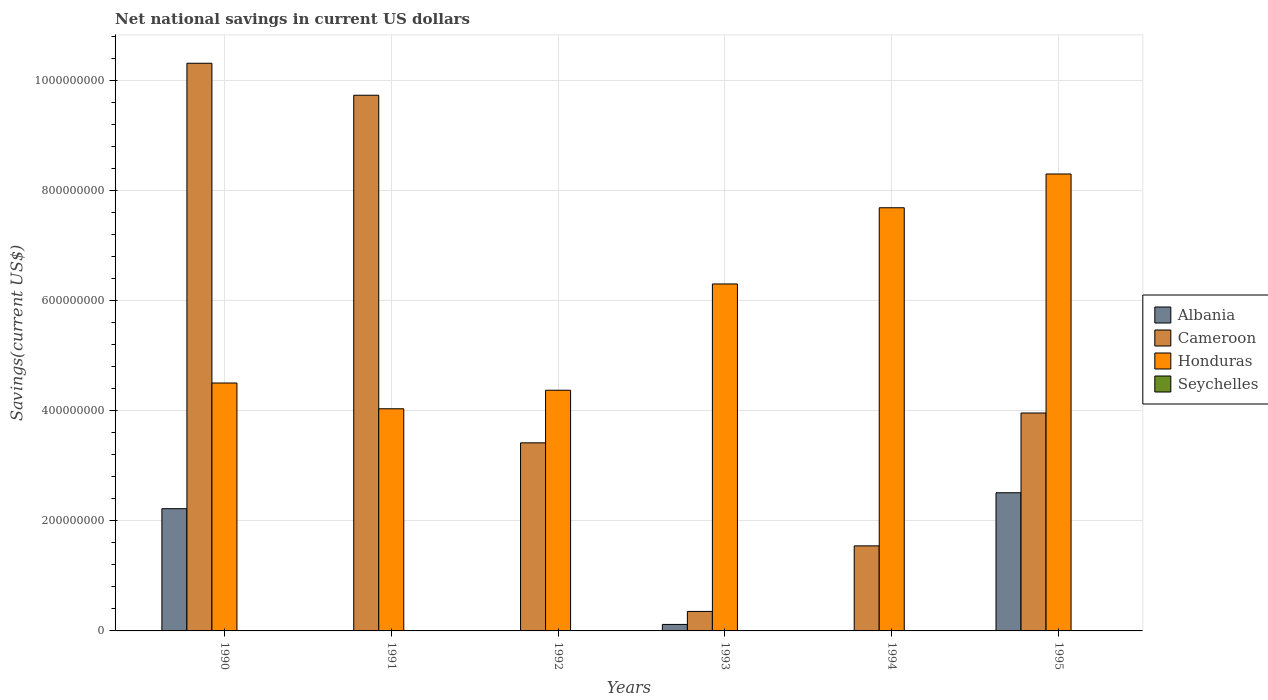How many groups of bars are there?
Keep it short and to the point. 6. Are the number of bars per tick equal to the number of legend labels?
Offer a terse response. No. Are the number of bars on each tick of the X-axis equal?
Keep it short and to the point. No. How many bars are there on the 6th tick from the right?
Give a very brief answer. 3. What is the net national savings in Albania in 1994?
Give a very brief answer. 0. Across all years, what is the maximum net national savings in Cameroon?
Offer a very short reply. 1.03e+09. Across all years, what is the minimum net national savings in Cameroon?
Your response must be concise. 3.54e+07. What is the difference between the net national savings in Honduras in 1994 and that in 1995?
Offer a terse response. -6.14e+07. What is the difference between the net national savings in Cameroon in 1992 and the net national savings in Honduras in 1993?
Your answer should be compact. -2.89e+08. What is the average net national savings in Albania per year?
Provide a short and direct response. 8.09e+07. In the year 1990, what is the difference between the net national savings in Honduras and net national savings in Cameroon?
Provide a short and direct response. -5.81e+08. What is the ratio of the net national savings in Cameroon in 1992 to that in 1994?
Provide a succinct answer. 2.21. What is the difference between the highest and the second highest net national savings in Albania?
Your answer should be very brief. 2.90e+07. What is the difference between the highest and the lowest net national savings in Cameroon?
Keep it short and to the point. 9.96e+08. In how many years, is the net national savings in Honduras greater than the average net national savings in Honduras taken over all years?
Your answer should be very brief. 3. Is it the case that in every year, the sum of the net national savings in Cameroon and net national savings in Honduras is greater than the sum of net national savings in Albania and net national savings in Seychelles?
Provide a succinct answer. Yes. Is it the case that in every year, the sum of the net national savings in Seychelles and net national savings in Albania is greater than the net national savings in Cameroon?
Provide a succinct answer. No. How many bars are there?
Your answer should be very brief. 15. Are all the bars in the graph horizontal?
Offer a very short reply. No. What is the difference between two consecutive major ticks on the Y-axis?
Keep it short and to the point. 2.00e+08. Does the graph contain grids?
Provide a short and direct response. Yes. How many legend labels are there?
Ensure brevity in your answer.  4. How are the legend labels stacked?
Offer a very short reply. Vertical. What is the title of the graph?
Provide a succinct answer. Net national savings in current US dollars. Does "Uruguay" appear as one of the legend labels in the graph?
Give a very brief answer. No. What is the label or title of the X-axis?
Make the answer very short. Years. What is the label or title of the Y-axis?
Offer a terse response. Savings(current US$). What is the Savings(current US$) in Albania in 1990?
Make the answer very short. 2.22e+08. What is the Savings(current US$) of Cameroon in 1990?
Provide a succinct answer. 1.03e+09. What is the Savings(current US$) in Honduras in 1990?
Your answer should be compact. 4.51e+08. What is the Savings(current US$) of Albania in 1991?
Offer a very short reply. 0. What is the Savings(current US$) in Cameroon in 1991?
Ensure brevity in your answer.  9.74e+08. What is the Savings(current US$) in Honduras in 1991?
Your answer should be very brief. 4.04e+08. What is the Savings(current US$) of Seychelles in 1991?
Make the answer very short. 0. What is the Savings(current US$) of Cameroon in 1992?
Give a very brief answer. 3.42e+08. What is the Savings(current US$) of Honduras in 1992?
Provide a succinct answer. 4.38e+08. What is the Savings(current US$) of Albania in 1993?
Provide a succinct answer. 1.18e+07. What is the Savings(current US$) in Cameroon in 1993?
Keep it short and to the point. 3.54e+07. What is the Savings(current US$) in Honduras in 1993?
Your answer should be compact. 6.31e+08. What is the Savings(current US$) of Seychelles in 1993?
Make the answer very short. 0. What is the Savings(current US$) of Cameroon in 1994?
Your response must be concise. 1.55e+08. What is the Savings(current US$) of Honduras in 1994?
Your response must be concise. 7.69e+08. What is the Savings(current US$) of Seychelles in 1994?
Offer a terse response. 0. What is the Savings(current US$) of Albania in 1995?
Give a very brief answer. 2.51e+08. What is the Savings(current US$) in Cameroon in 1995?
Offer a terse response. 3.96e+08. What is the Savings(current US$) of Honduras in 1995?
Make the answer very short. 8.31e+08. What is the Savings(current US$) in Seychelles in 1995?
Keep it short and to the point. 0. Across all years, what is the maximum Savings(current US$) of Albania?
Ensure brevity in your answer.  2.51e+08. Across all years, what is the maximum Savings(current US$) of Cameroon?
Offer a terse response. 1.03e+09. Across all years, what is the maximum Savings(current US$) in Honduras?
Provide a succinct answer. 8.31e+08. Across all years, what is the minimum Savings(current US$) in Albania?
Make the answer very short. 0. Across all years, what is the minimum Savings(current US$) in Cameroon?
Your response must be concise. 3.54e+07. Across all years, what is the minimum Savings(current US$) of Honduras?
Make the answer very short. 4.04e+08. What is the total Savings(current US$) of Albania in the graph?
Offer a terse response. 4.85e+08. What is the total Savings(current US$) of Cameroon in the graph?
Your response must be concise. 2.93e+09. What is the total Savings(current US$) in Honduras in the graph?
Give a very brief answer. 3.52e+09. What is the total Savings(current US$) of Seychelles in the graph?
Make the answer very short. 0. What is the difference between the Savings(current US$) in Cameroon in 1990 and that in 1991?
Your answer should be very brief. 5.81e+07. What is the difference between the Savings(current US$) in Honduras in 1990 and that in 1991?
Keep it short and to the point. 4.69e+07. What is the difference between the Savings(current US$) in Cameroon in 1990 and that in 1992?
Your answer should be compact. 6.90e+08. What is the difference between the Savings(current US$) of Honduras in 1990 and that in 1992?
Give a very brief answer. 1.32e+07. What is the difference between the Savings(current US$) of Albania in 1990 and that in 1993?
Provide a short and direct response. 2.10e+08. What is the difference between the Savings(current US$) in Cameroon in 1990 and that in 1993?
Your answer should be compact. 9.96e+08. What is the difference between the Savings(current US$) in Honduras in 1990 and that in 1993?
Give a very brief answer. -1.80e+08. What is the difference between the Savings(current US$) of Cameroon in 1990 and that in 1994?
Ensure brevity in your answer.  8.77e+08. What is the difference between the Savings(current US$) in Honduras in 1990 and that in 1994?
Your response must be concise. -3.19e+08. What is the difference between the Savings(current US$) of Albania in 1990 and that in 1995?
Your answer should be very brief. -2.90e+07. What is the difference between the Savings(current US$) in Cameroon in 1990 and that in 1995?
Provide a succinct answer. 6.36e+08. What is the difference between the Savings(current US$) in Honduras in 1990 and that in 1995?
Ensure brevity in your answer.  -3.80e+08. What is the difference between the Savings(current US$) in Cameroon in 1991 and that in 1992?
Your answer should be very brief. 6.32e+08. What is the difference between the Savings(current US$) in Honduras in 1991 and that in 1992?
Offer a very short reply. -3.37e+07. What is the difference between the Savings(current US$) of Cameroon in 1991 and that in 1993?
Your answer should be compact. 9.38e+08. What is the difference between the Savings(current US$) of Honduras in 1991 and that in 1993?
Your response must be concise. -2.27e+08. What is the difference between the Savings(current US$) of Cameroon in 1991 and that in 1994?
Your answer should be very brief. 8.19e+08. What is the difference between the Savings(current US$) of Honduras in 1991 and that in 1994?
Offer a terse response. -3.65e+08. What is the difference between the Savings(current US$) in Cameroon in 1991 and that in 1995?
Offer a terse response. 5.78e+08. What is the difference between the Savings(current US$) of Honduras in 1991 and that in 1995?
Keep it short and to the point. -4.27e+08. What is the difference between the Savings(current US$) in Cameroon in 1992 and that in 1993?
Offer a terse response. 3.06e+08. What is the difference between the Savings(current US$) in Honduras in 1992 and that in 1993?
Your answer should be compact. -1.93e+08. What is the difference between the Savings(current US$) in Cameroon in 1992 and that in 1994?
Ensure brevity in your answer.  1.87e+08. What is the difference between the Savings(current US$) in Honduras in 1992 and that in 1994?
Your answer should be compact. -3.32e+08. What is the difference between the Savings(current US$) of Cameroon in 1992 and that in 1995?
Keep it short and to the point. -5.42e+07. What is the difference between the Savings(current US$) in Honduras in 1992 and that in 1995?
Your answer should be very brief. -3.93e+08. What is the difference between the Savings(current US$) in Cameroon in 1993 and that in 1994?
Your answer should be compact. -1.19e+08. What is the difference between the Savings(current US$) in Honduras in 1993 and that in 1994?
Give a very brief answer. -1.39e+08. What is the difference between the Savings(current US$) of Albania in 1993 and that in 1995?
Keep it short and to the point. -2.39e+08. What is the difference between the Savings(current US$) of Cameroon in 1993 and that in 1995?
Ensure brevity in your answer.  -3.61e+08. What is the difference between the Savings(current US$) of Honduras in 1993 and that in 1995?
Give a very brief answer. -2.00e+08. What is the difference between the Savings(current US$) in Cameroon in 1994 and that in 1995?
Give a very brief answer. -2.42e+08. What is the difference between the Savings(current US$) of Honduras in 1994 and that in 1995?
Give a very brief answer. -6.14e+07. What is the difference between the Savings(current US$) of Albania in 1990 and the Savings(current US$) of Cameroon in 1991?
Keep it short and to the point. -7.52e+08. What is the difference between the Savings(current US$) in Albania in 1990 and the Savings(current US$) in Honduras in 1991?
Your response must be concise. -1.82e+08. What is the difference between the Savings(current US$) in Cameroon in 1990 and the Savings(current US$) in Honduras in 1991?
Ensure brevity in your answer.  6.28e+08. What is the difference between the Savings(current US$) in Albania in 1990 and the Savings(current US$) in Cameroon in 1992?
Your response must be concise. -1.20e+08. What is the difference between the Savings(current US$) of Albania in 1990 and the Savings(current US$) of Honduras in 1992?
Keep it short and to the point. -2.15e+08. What is the difference between the Savings(current US$) in Cameroon in 1990 and the Savings(current US$) in Honduras in 1992?
Provide a short and direct response. 5.94e+08. What is the difference between the Savings(current US$) in Albania in 1990 and the Savings(current US$) in Cameroon in 1993?
Ensure brevity in your answer.  1.87e+08. What is the difference between the Savings(current US$) of Albania in 1990 and the Savings(current US$) of Honduras in 1993?
Give a very brief answer. -4.09e+08. What is the difference between the Savings(current US$) in Cameroon in 1990 and the Savings(current US$) in Honduras in 1993?
Provide a succinct answer. 4.01e+08. What is the difference between the Savings(current US$) in Albania in 1990 and the Savings(current US$) in Cameroon in 1994?
Ensure brevity in your answer.  6.76e+07. What is the difference between the Savings(current US$) in Albania in 1990 and the Savings(current US$) in Honduras in 1994?
Your answer should be compact. -5.47e+08. What is the difference between the Savings(current US$) of Cameroon in 1990 and the Savings(current US$) of Honduras in 1994?
Your response must be concise. 2.63e+08. What is the difference between the Savings(current US$) of Albania in 1990 and the Savings(current US$) of Cameroon in 1995?
Offer a very short reply. -1.74e+08. What is the difference between the Savings(current US$) in Albania in 1990 and the Savings(current US$) in Honduras in 1995?
Keep it short and to the point. -6.08e+08. What is the difference between the Savings(current US$) of Cameroon in 1990 and the Savings(current US$) of Honduras in 1995?
Ensure brevity in your answer.  2.01e+08. What is the difference between the Savings(current US$) of Cameroon in 1991 and the Savings(current US$) of Honduras in 1992?
Give a very brief answer. 5.36e+08. What is the difference between the Savings(current US$) in Cameroon in 1991 and the Savings(current US$) in Honduras in 1993?
Provide a short and direct response. 3.43e+08. What is the difference between the Savings(current US$) of Cameroon in 1991 and the Savings(current US$) of Honduras in 1994?
Your answer should be compact. 2.05e+08. What is the difference between the Savings(current US$) in Cameroon in 1991 and the Savings(current US$) in Honduras in 1995?
Give a very brief answer. 1.43e+08. What is the difference between the Savings(current US$) in Cameroon in 1992 and the Savings(current US$) in Honduras in 1993?
Your answer should be compact. -2.89e+08. What is the difference between the Savings(current US$) in Cameroon in 1992 and the Savings(current US$) in Honduras in 1994?
Provide a short and direct response. -4.27e+08. What is the difference between the Savings(current US$) of Cameroon in 1992 and the Savings(current US$) of Honduras in 1995?
Keep it short and to the point. -4.89e+08. What is the difference between the Savings(current US$) in Albania in 1993 and the Savings(current US$) in Cameroon in 1994?
Keep it short and to the point. -1.43e+08. What is the difference between the Savings(current US$) of Albania in 1993 and the Savings(current US$) of Honduras in 1994?
Offer a terse response. -7.57e+08. What is the difference between the Savings(current US$) in Cameroon in 1993 and the Savings(current US$) in Honduras in 1994?
Offer a terse response. -7.34e+08. What is the difference between the Savings(current US$) in Albania in 1993 and the Savings(current US$) in Cameroon in 1995?
Offer a terse response. -3.84e+08. What is the difference between the Savings(current US$) of Albania in 1993 and the Savings(current US$) of Honduras in 1995?
Your answer should be compact. -8.19e+08. What is the difference between the Savings(current US$) of Cameroon in 1993 and the Savings(current US$) of Honduras in 1995?
Ensure brevity in your answer.  -7.95e+08. What is the difference between the Savings(current US$) of Cameroon in 1994 and the Savings(current US$) of Honduras in 1995?
Provide a short and direct response. -6.76e+08. What is the average Savings(current US$) of Albania per year?
Your answer should be very brief. 8.09e+07. What is the average Savings(current US$) of Cameroon per year?
Make the answer very short. 4.89e+08. What is the average Savings(current US$) in Honduras per year?
Keep it short and to the point. 5.87e+08. In the year 1990, what is the difference between the Savings(current US$) in Albania and Savings(current US$) in Cameroon?
Give a very brief answer. -8.10e+08. In the year 1990, what is the difference between the Savings(current US$) of Albania and Savings(current US$) of Honduras?
Provide a succinct answer. -2.29e+08. In the year 1990, what is the difference between the Savings(current US$) of Cameroon and Savings(current US$) of Honduras?
Your answer should be compact. 5.81e+08. In the year 1991, what is the difference between the Savings(current US$) in Cameroon and Savings(current US$) in Honduras?
Give a very brief answer. 5.70e+08. In the year 1992, what is the difference between the Savings(current US$) of Cameroon and Savings(current US$) of Honduras?
Keep it short and to the point. -9.56e+07. In the year 1993, what is the difference between the Savings(current US$) of Albania and Savings(current US$) of Cameroon?
Make the answer very short. -2.37e+07. In the year 1993, what is the difference between the Savings(current US$) of Albania and Savings(current US$) of Honduras?
Your answer should be very brief. -6.19e+08. In the year 1993, what is the difference between the Savings(current US$) in Cameroon and Savings(current US$) in Honduras?
Offer a terse response. -5.95e+08. In the year 1994, what is the difference between the Savings(current US$) in Cameroon and Savings(current US$) in Honduras?
Make the answer very short. -6.15e+08. In the year 1995, what is the difference between the Savings(current US$) of Albania and Savings(current US$) of Cameroon?
Ensure brevity in your answer.  -1.45e+08. In the year 1995, what is the difference between the Savings(current US$) of Albania and Savings(current US$) of Honduras?
Make the answer very short. -5.79e+08. In the year 1995, what is the difference between the Savings(current US$) in Cameroon and Savings(current US$) in Honduras?
Your response must be concise. -4.34e+08. What is the ratio of the Savings(current US$) of Cameroon in 1990 to that in 1991?
Provide a succinct answer. 1.06. What is the ratio of the Savings(current US$) in Honduras in 1990 to that in 1991?
Your answer should be very brief. 1.12. What is the ratio of the Savings(current US$) of Cameroon in 1990 to that in 1992?
Give a very brief answer. 3.02. What is the ratio of the Savings(current US$) of Honduras in 1990 to that in 1992?
Ensure brevity in your answer.  1.03. What is the ratio of the Savings(current US$) in Albania in 1990 to that in 1993?
Your answer should be very brief. 18.85. What is the ratio of the Savings(current US$) in Cameroon in 1990 to that in 1993?
Your answer should be compact. 29.11. What is the ratio of the Savings(current US$) in Honduras in 1990 to that in 1993?
Keep it short and to the point. 0.71. What is the ratio of the Savings(current US$) of Cameroon in 1990 to that in 1994?
Your answer should be very brief. 6.67. What is the ratio of the Savings(current US$) in Honduras in 1990 to that in 1994?
Offer a very short reply. 0.59. What is the ratio of the Savings(current US$) of Albania in 1990 to that in 1995?
Provide a short and direct response. 0.88. What is the ratio of the Savings(current US$) of Cameroon in 1990 to that in 1995?
Your response must be concise. 2.6. What is the ratio of the Savings(current US$) of Honduras in 1990 to that in 1995?
Make the answer very short. 0.54. What is the ratio of the Savings(current US$) of Cameroon in 1991 to that in 1992?
Offer a terse response. 2.85. What is the ratio of the Savings(current US$) of Honduras in 1991 to that in 1992?
Your answer should be very brief. 0.92. What is the ratio of the Savings(current US$) of Cameroon in 1991 to that in 1993?
Provide a succinct answer. 27.47. What is the ratio of the Savings(current US$) in Honduras in 1991 to that in 1993?
Make the answer very short. 0.64. What is the ratio of the Savings(current US$) of Cameroon in 1991 to that in 1994?
Make the answer very short. 6.3. What is the ratio of the Savings(current US$) in Honduras in 1991 to that in 1994?
Make the answer very short. 0.53. What is the ratio of the Savings(current US$) of Cameroon in 1991 to that in 1995?
Your answer should be very brief. 2.46. What is the ratio of the Savings(current US$) of Honduras in 1991 to that in 1995?
Ensure brevity in your answer.  0.49. What is the ratio of the Savings(current US$) in Cameroon in 1992 to that in 1993?
Ensure brevity in your answer.  9.65. What is the ratio of the Savings(current US$) in Honduras in 1992 to that in 1993?
Provide a short and direct response. 0.69. What is the ratio of the Savings(current US$) in Cameroon in 1992 to that in 1994?
Your answer should be very brief. 2.21. What is the ratio of the Savings(current US$) of Honduras in 1992 to that in 1994?
Your answer should be compact. 0.57. What is the ratio of the Savings(current US$) of Cameroon in 1992 to that in 1995?
Your answer should be very brief. 0.86. What is the ratio of the Savings(current US$) in Honduras in 1992 to that in 1995?
Provide a short and direct response. 0.53. What is the ratio of the Savings(current US$) in Cameroon in 1993 to that in 1994?
Your answer should be compact. 0.23. What is the ratio of the Savings(current US$) in Honduras in 1993 to that in 1994?
Provide a short and direct response. 0.82. What is the ratio of the Savings(current US$) in Albania in 1993 to that in 1995?
Keep it short and to the point. 0.05. What is the ratio of the Savings(current US$) of Cameroon in 1993 to that in 1995?
Offer a very short reply. 0.09. What is the ratio of the Savings(current US$) of Honduras in 1993 to that in 1995?
Keep it short and to the point. 0.76. What is the ratio of the Savings(current US$) of Cameroon in 1994 to that in 1995?
Your response must be concise. 0.39. What is the ratio of the Savings(current US$) in Honduras in 1994 to that in 1995?
Your answer should be very brief. 0.93. What is the difference between the highest and the second highest Savings(current US$) in Albania?
Offer a very short reply. 2.90e+07. What is the difference between the highest and the second highest Savings(current US$) of Cameroon?
Your answer should be very brief. 5.81e+07. What is the difference between the highest and the second highest Savings(current US$) in Honduras?
Your answer should be compact. 6.14e+07. What is the difference between the highest and the lowest Savings(current US$) in Albania?
Your answer should be very brief. 2.51e+08. What is the difference between the highest and the lowest Savings(current US$) in Cameroon?
Make the answer very short. 9.96e+08. What is the difference between the highest and the lowest Savings(current US$) in Honduras?
Keep it short and to the point. 4.27e+08. 